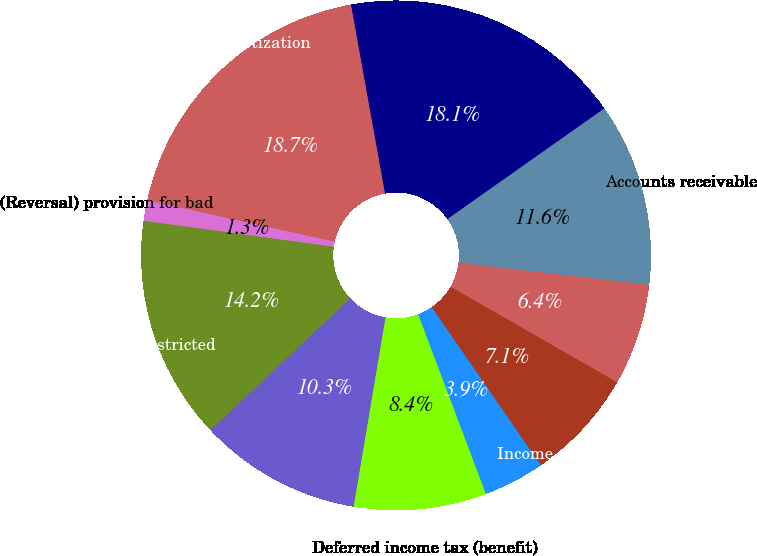<chart> <loc_0><loc_0><loc_500><loc_500><pie_chart><fcel>Net income (loss)<fcel>Depreciation and amortization<fcel>(Reversal) provision for bad<fcel>Amortization of restricted<fcel>Amortization of bond discounts<fcel>Deferred income tax (benefit)<fcel>Losses (gains) on sales of<fcel>Income applicable to minority<fcel>Other<fcel>Accounts receivable<nl><fcel>18.06%<fcel>18.7%<fcel>1.3%<fcel>14.19%<fcel>10.32%<fcel>8.39%<fcel>3.88%<fcel>7.1%<fcel>6.45%<fcel>11.61%<nl></chart> 